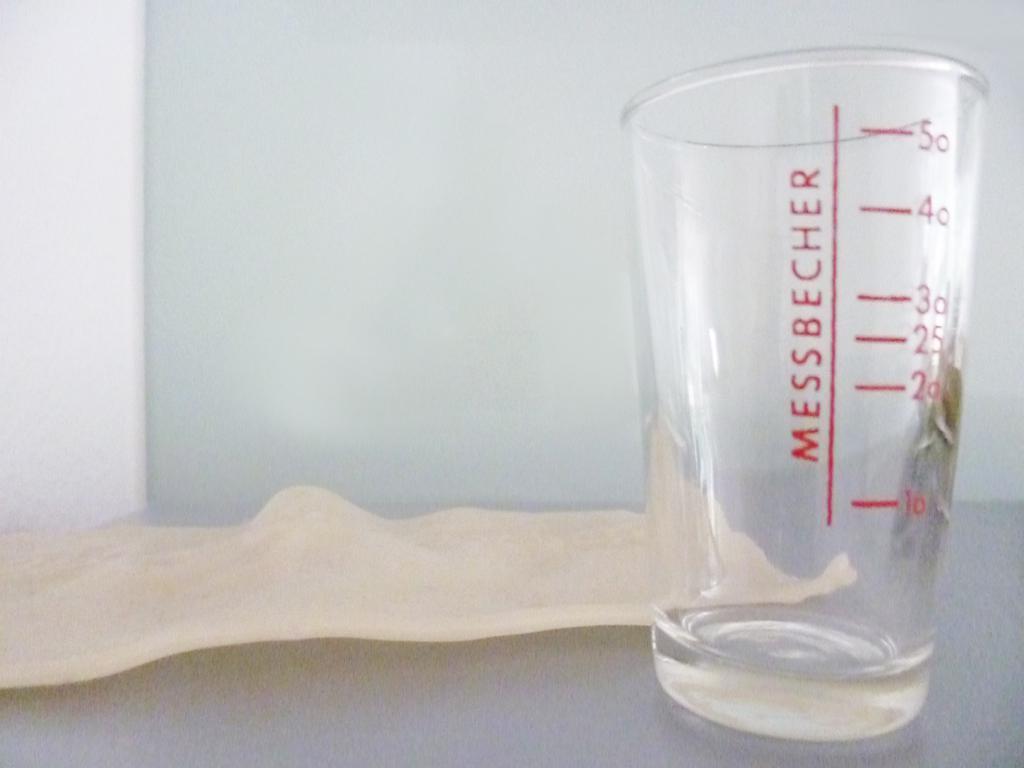What kind of glass is this?
Make the answer very short. Messbecher. What brand is shown?
Provide a succinct answer. Messbecher. 